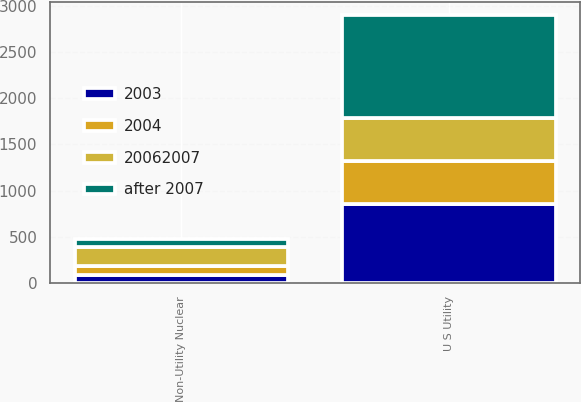Convert chart. <chart><loc_0><loc_0><loc_500><loc_500><stacked_bar_chart><ecel><fcel>U S Utility<fcel>Non-Utility Nuclear<nl><fcel>after 2007<fcel>1111<fcel>87<nl><fcel>2003<fcel>855<fcel>91<nl><fcel>2004<fcel>470<fcel>95<nl><fcel>20062007<fcel>466<fcel>205<nl></chart> 